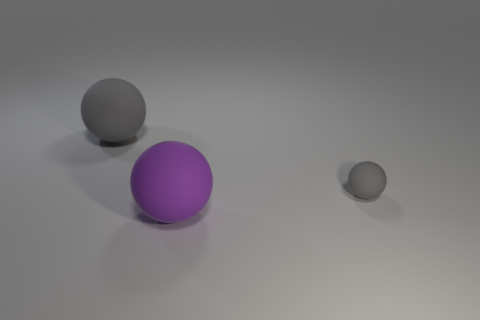How many objects are rubber objects on the right side of the purple sphere or gray things that are in front of the big gray sphere?
Your answer should be compact. 1. What number of other objects are there of the same color as the tiny ball?
Your answer should be very brief. 1. Are there more matte objects that are in front of the large gray thing than gray spheres to the right of the big purple rubber ball?
Your response must be concise. Yes. How many cylinders are either brown shiny objects or large objects?
Give a very brief answer. 0. How many things are either big rubber spheres that are behind the tiny matte object or purple matte objects?
Your response must be concise. 2. What shape is the big object that is on the right side of the big rubber thing that is behind the thing to the right of the purple thing?
Your answer should be very brief. Sphere. What number of gray objects have the same shape as the purple object?
Make the answer very short. 2. There is a big object that is the same color as the tiny rubber ball; what is it made of?
Offer a very short reply. Rubber. Does the purple object have the same material as the big gray object?
Give a very brief answer. Yes. There is a gray matte sphere right of the large rubber sphere behind the big purple rubber sphere; how many large rubber spheres are behind it?
Your response must be concise. 1. 